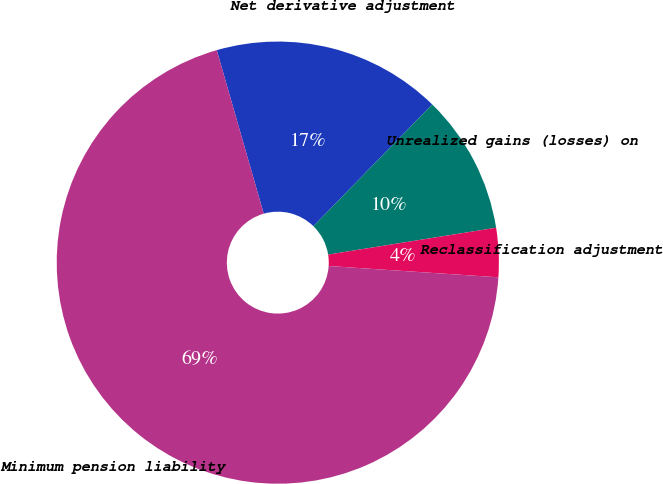Convert chart to OTSL. <chart><loc_0><loc_0><loc_500><loc_500><pie_chart><fcel>Net derivative adjustment<fcel>Unrealized gains (losses) on<fcel>Reclassification adjustment<fcel>Minimum pension liability<nl><fcel>16.76%<fcel>10.17%<fcel>3.58%<fcel>69.49%<nl></chart> 